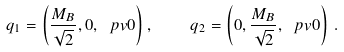Convert formula to latex. <formula><loc_0><loc_0><loc_500><loc_500>q _ { 1 } = \left ( \frac { M _ { B } } { \sqrt { 2 } } , 0 , \ p v { 0 } \right ) , \quad q _ { 2 } = \left ( 0 , \frac { M _ { B } } { \sqrt { 2 } } , \ p v { 0 } \right ) \, .</formula> 